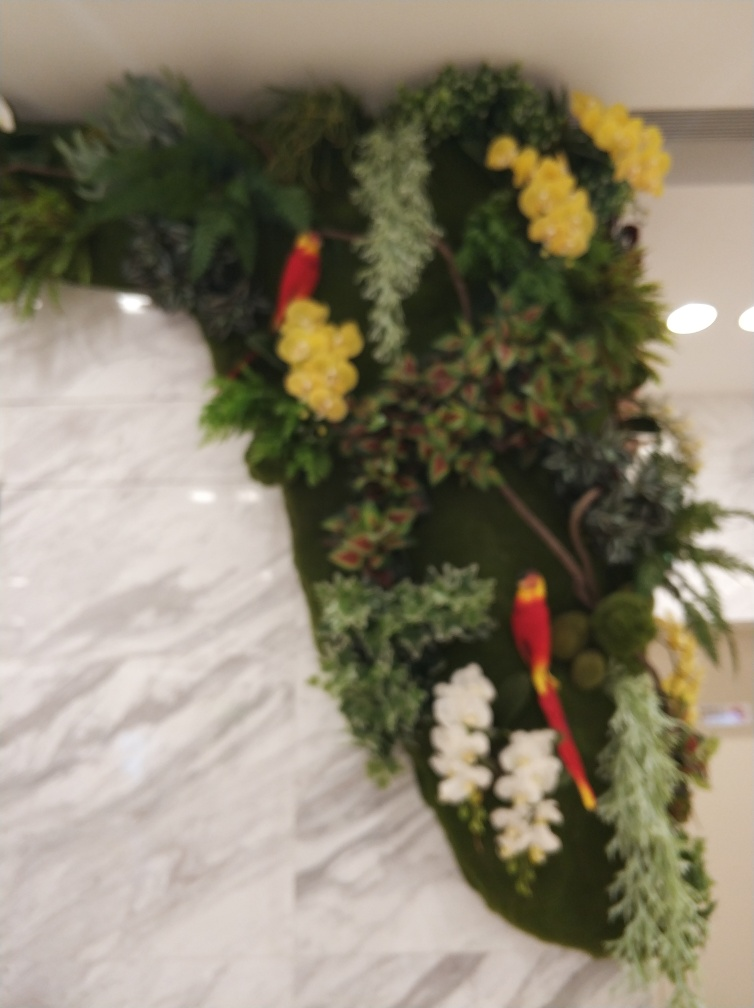Is this a natural setting or a staged one? From the appearance of the image, this seems to be a staged setting. The foliage around the bird has an arranged, decorative quality that suggests it might be part of an indoor display or decor. What makes you say that the setting is staged? The uniform lighting and the neat arrangement of the plants indicate that this environment is likely man-made. Natural settings typically show more irregularity and chaos in plant growth, as well as varying light conditions. 